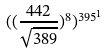<formula> <loc_0><loc_0><loc_500><loc_500>( ( \frac { 4 4 2 } { \sqrt { 3 8 9 } } ) ^ { 8 } ) ^ { 3 9 5 ^ { 1 } }</formula> 